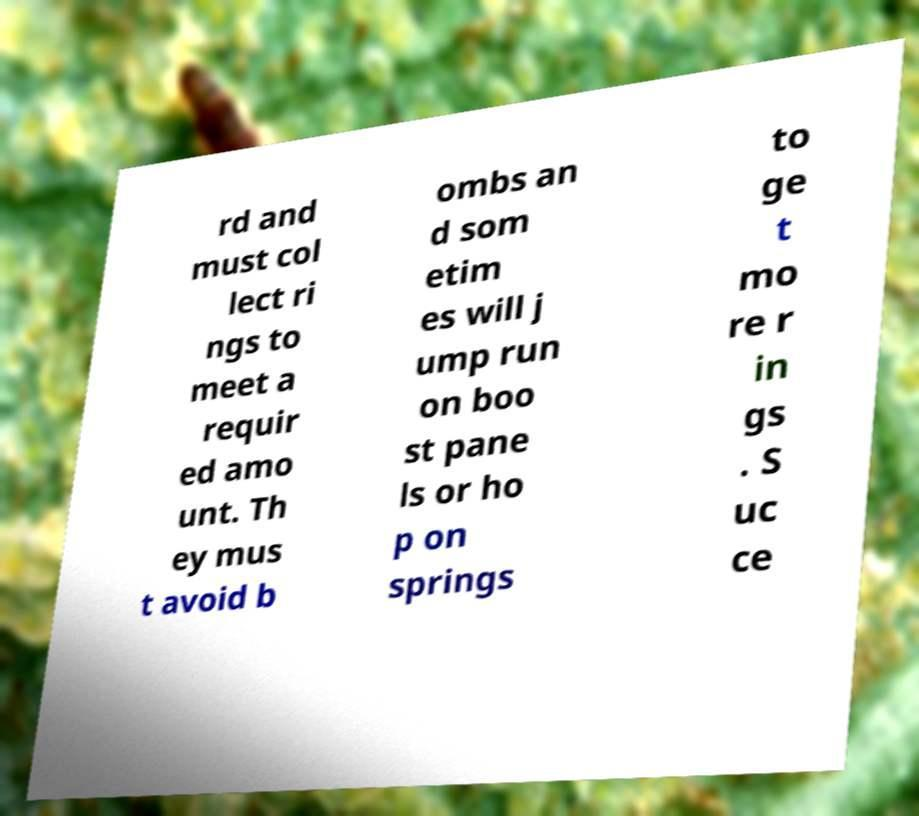I need the written content from this picture converted into text. Can you do that? rd and must col lect ri ngs to meet a requir ed amo unt. Th ey mus t avoid b ombs an d som etim es will j ump run on boo st pane ls or ho p on springs to ge t mo re r in gs . S uc ce 